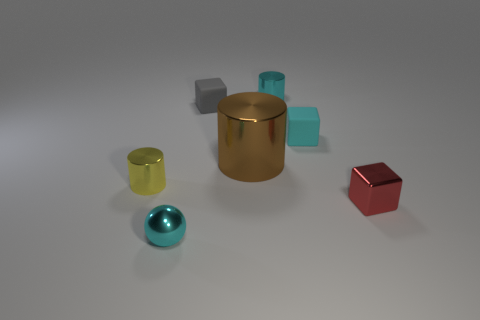There is a tiny rubber block that is to the right of the tiny cyan shiny cylinder; does it have the same color as the metallic object that is in front of the small red thing?
Your answer should be very brief. Yes. How many shiny objects are behind the red object?
Your answer should be compact. 3. What number of small objects have the same color as the tiny shiny ball?
Keep it short and to the point. 2. Do the small cylinder to the right of the big metallic cylinder and the small gray cube have the same material?
Provide a short and direct response. No. What number of gray objects are the same material as the big brown cylinder?
Ensure brevity in your answer.  0. Is the number of cyan objects that are in front of the cyan matte block greater than the number of large red metal things?
Keep it short and to the point. Yes. The cylinder that is the same color as the small shiny ball is what size?
Provide a short and direct response. Small. Are there any other rubber things that have the same shape as the gray thing?
Offer a very short reply. Yes. How many objects are big yellow cylinders or cyan blocks?
Provide a succinct answer. 1. How many small cyan shiny objects are behind the tiny object that is left of the small shiny thing in front of the small red block?
Provide a short and direct response. 1. 